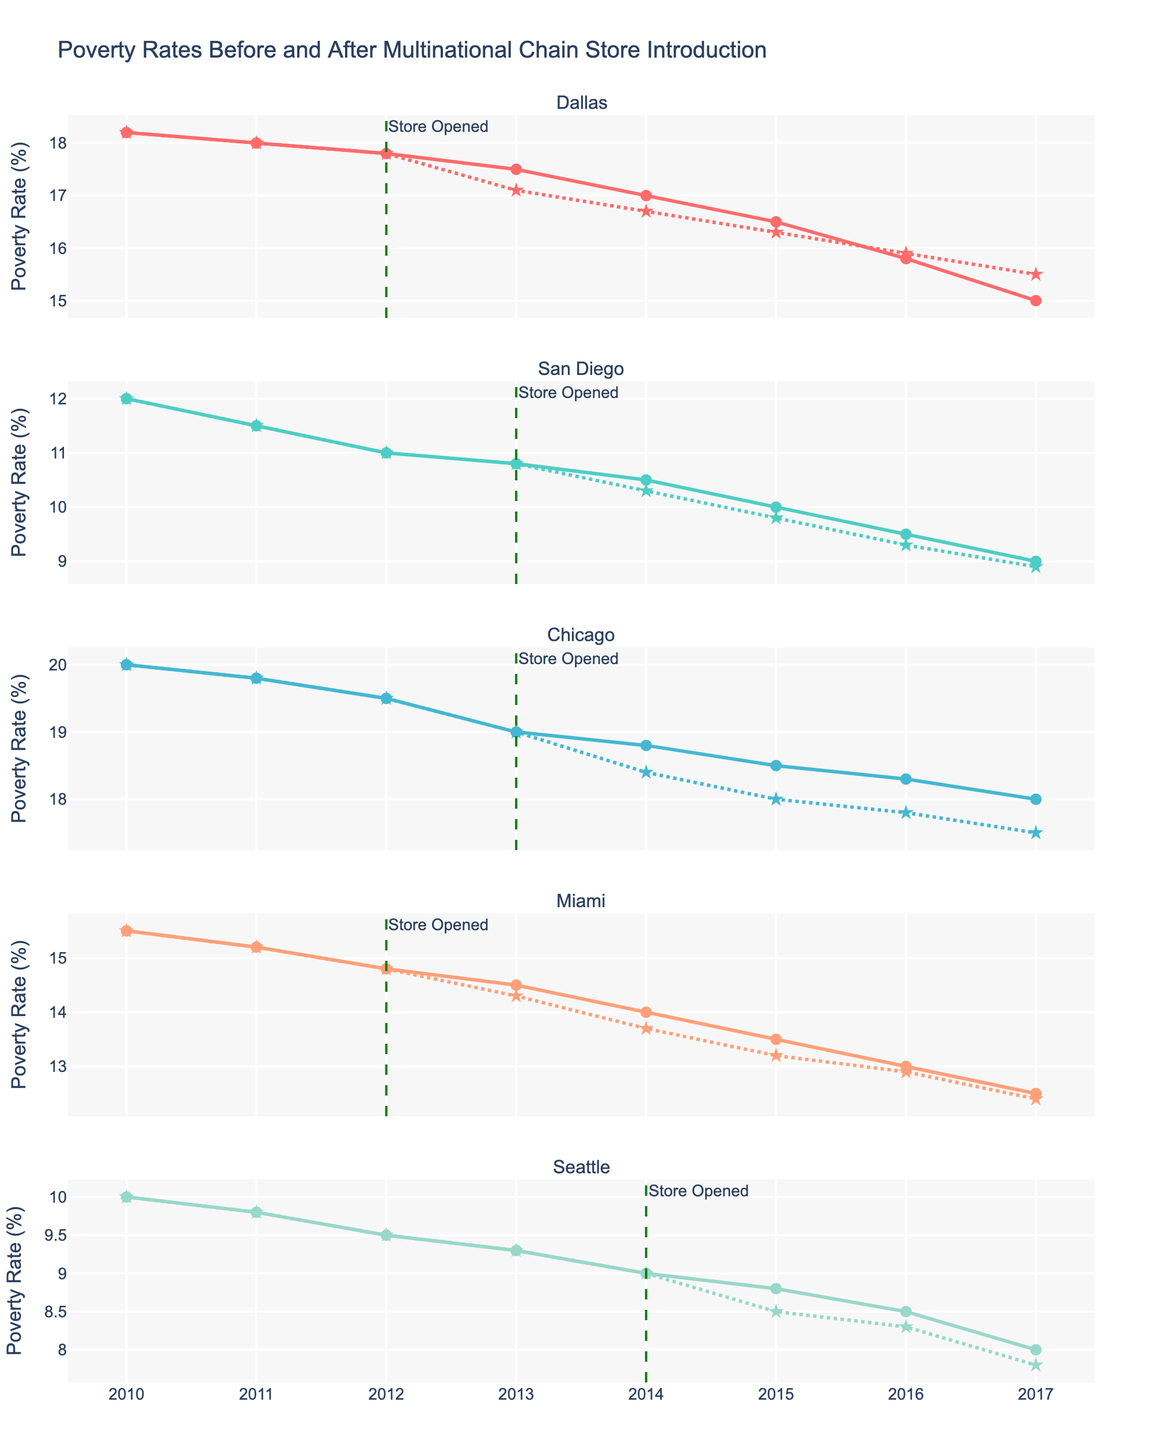What is the trend of poverty rates in Dallas before the multinational chain store opened? The poverty rate in Dallas before the store opened decreased from 18.2% in 2010 to 17.8% in 2012.
Answer: Decreasing What year did the multinational chain store open in Miami? The vertical dashed line and annotation indicate that the store opened in 2012.
Answer: 2012 How much did the poverty rate change in Chicago from 2010 to 2017 after the multinational chain store opened? In 2010, the poverty rate was 20%, and in 2017 it was 17.5%. Subtracting the latter from the former gives the change: 20 - 17.5 = 2.5%.
Answer: 2.5% Compare the poverty rates in Seattle and San Diego in 2014 after the chain store opened. Which community had a lower rate? In 2014, Seattle had a poverty rate of 9.0% and San Diego had a rate of 10.3%. Seattle's rate was lower.
Answer: Seattle What is the average poverty rate in Dallas one year after the multinational chain store opened? The store opened in 2012, so we look at the poverty rates in 2013, 2014, and 2015. The rates are 17.1%, 16.7%, and 16.3%. The average is (17.1 + 16.7 + 16.3) / 3 = 16.7%.
Answer: 16.7% Did the poverty rate in Miami increase or decrease in the year immediately after the store opened? The store opened in 2012, and the poverty rate decreased from 14.8% in 2012 to 14.3% in 2013.
Answer: Decrease Which community showed the most significant decrease in poverty rates from before to after the store was opened? Calculate the difference for each community from before to after the store opened. Dallas: 18.2 - 15.5 = 2.7%, San Diego: 12.0 - 8.9 = 3.1%, Chicago: 20.0 - 17.5 = 2.5%, Miami: 15.5 - 12.4 = 3.1%, Seattle: 10.0 - 7.8 = 2.2%. San Diego and Miami both showed the largest decrease at 3.1%.
Answer: San Diego and Miami 